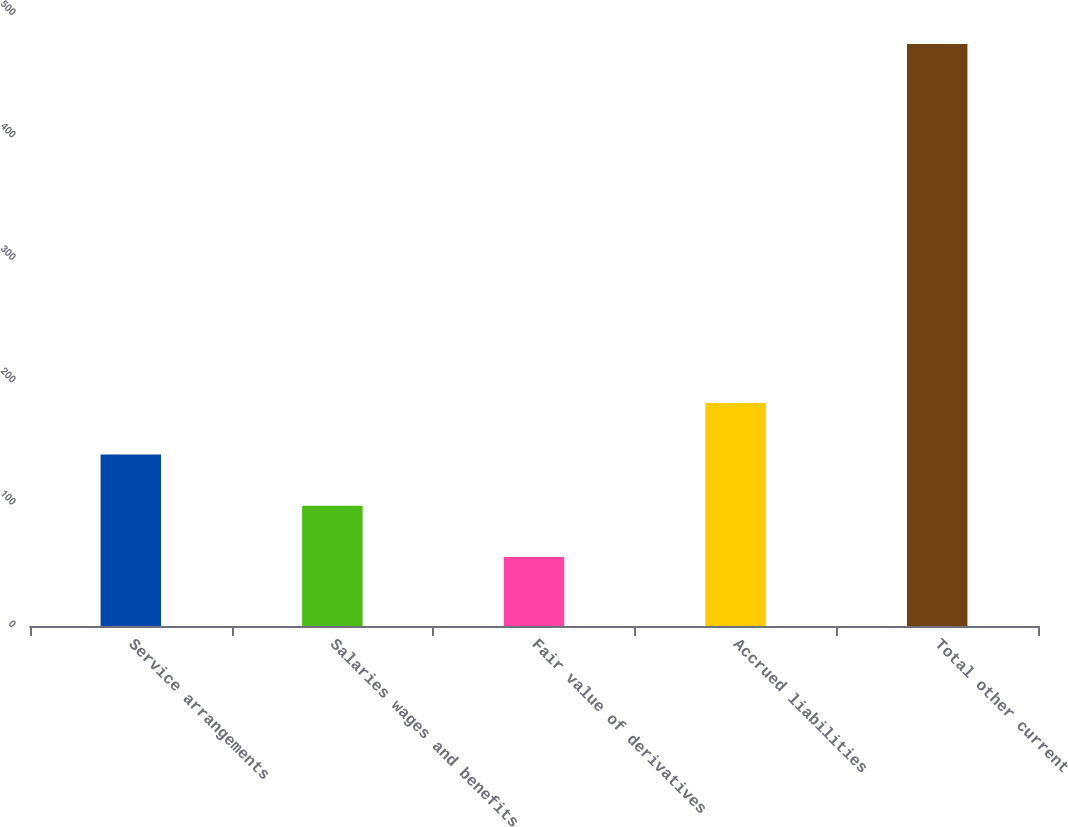<chart> <loc_0><loc_0><loc_500><loc_500><bar_chart><fcel>Service arrangements<fcel>Salaries wages and benefits<fcel>Fair value of derivatives<fcel>Accrued liabilities<fcel>Total other current<nl><fcel>140.2<fcel>98.3<fcel>56.4<fcel>182.1<fcel>475.4<nl></chart> 